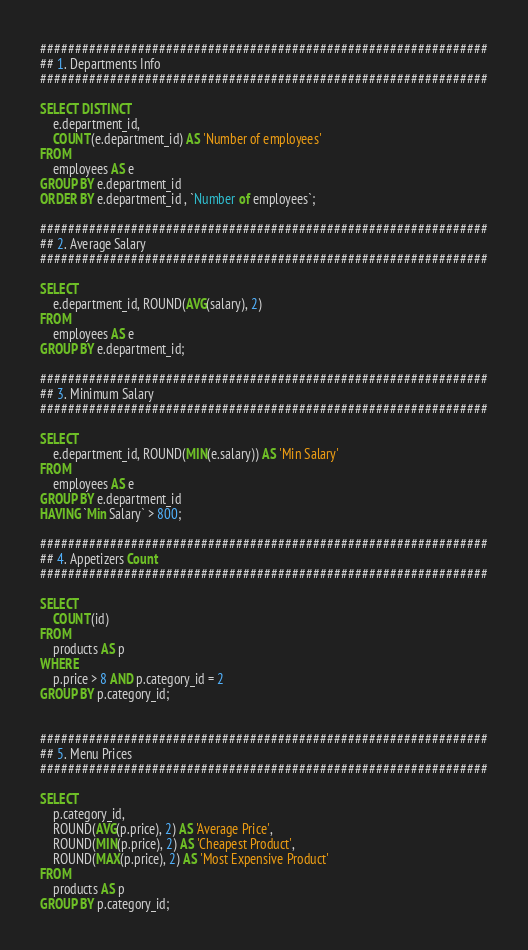Convert code to text. <code><loc_0><loc_0><loc_500><loc_500><_SQL_>################################################################
## 1. Departments Info 
################################################################

SELECT DISTINCT
    e.department_id,
    COUNT(e.department_id) AS 'Number of employees'
FROM
    employees AS e
GROUP BY e.department_id
ORDER BY e.department_id , `Number of employees`;

################################################################
## 2. Average Salary
################################################################

SELECT 
    e.department_id, ROUND(AVG(salary), 2)
FROM
    employees AS e
GROUP BY e.department_id;

################################################################
## 3. Minimum Salary
################################################################

SELECT 
    e.department_id, ROUND(MIN(e.salary)) AS 'Min Salary'
FROM
    employees AS e
GROUP BY e.department_id
HAVING `Min Salary` > 800;

################################################################
## 4. Appetizers Count
################################################################

SELECT 
    COUNT(id)
FROM
    products AS p
WHERE
    p.price > 8 AND p.category_id = 2
GROUP BY p.category_id;


################################################################
## 5. Menu Prices 
################################################################

SELECT 
    p.category_id,
    ROUND(AVG(p.price), 2) AS 'Average Price',
    ROUND(MIN(p.price), 2) AS 'Cheapest Product',
    ROUND(MAX(p.price), 2) AS 'Most Expensive Product'
FROM
    products AS p
GROUP BY p.category_id;







</code> 